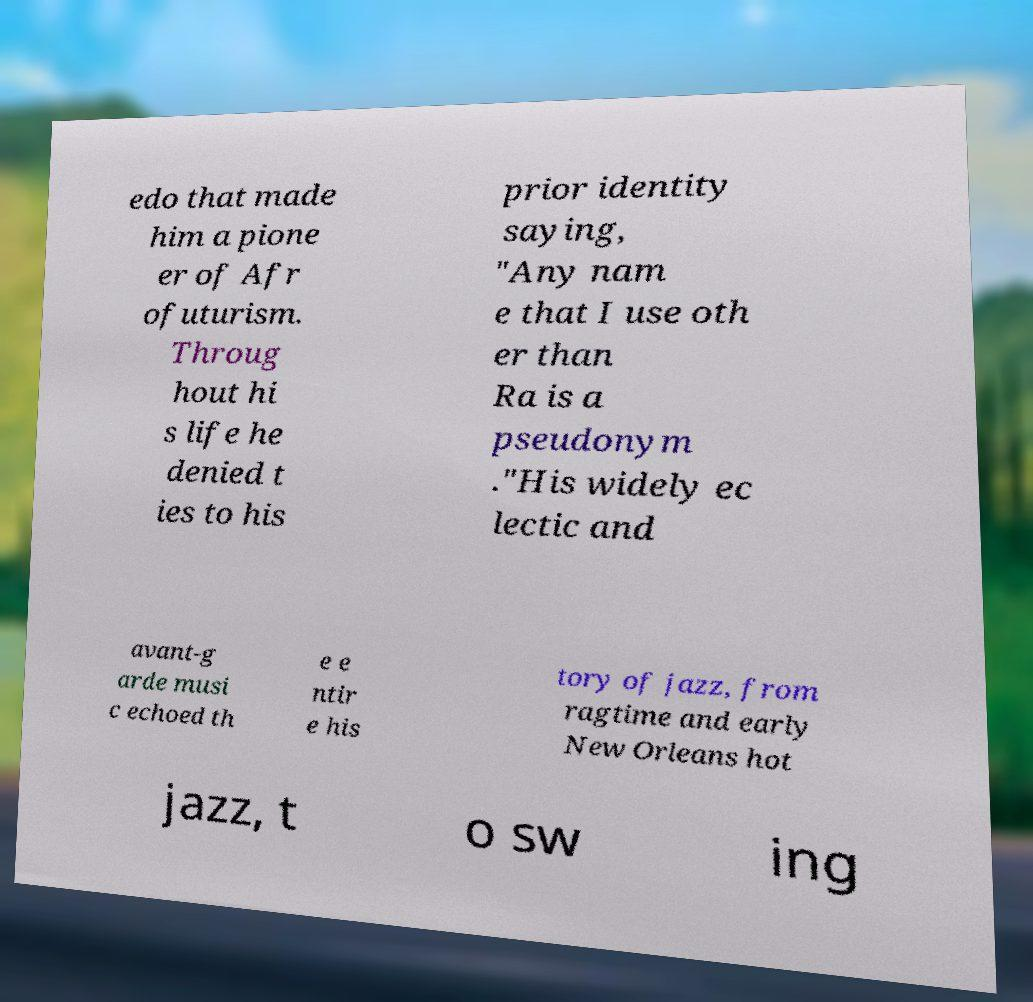Please identify and transcribe the text found in this image. edo that made him a pione er of Afr ofuturism. Throug hout hi s life he denied t ies to his prior identity saying, "Any nam e that I use oth er than Ra is a pseudonym ."His widely ec lectic and avant-g arde musi c echoed th e e ntir e his tory of jazz, from ragtime and early New Orleans hot jazz, t o sw ing 